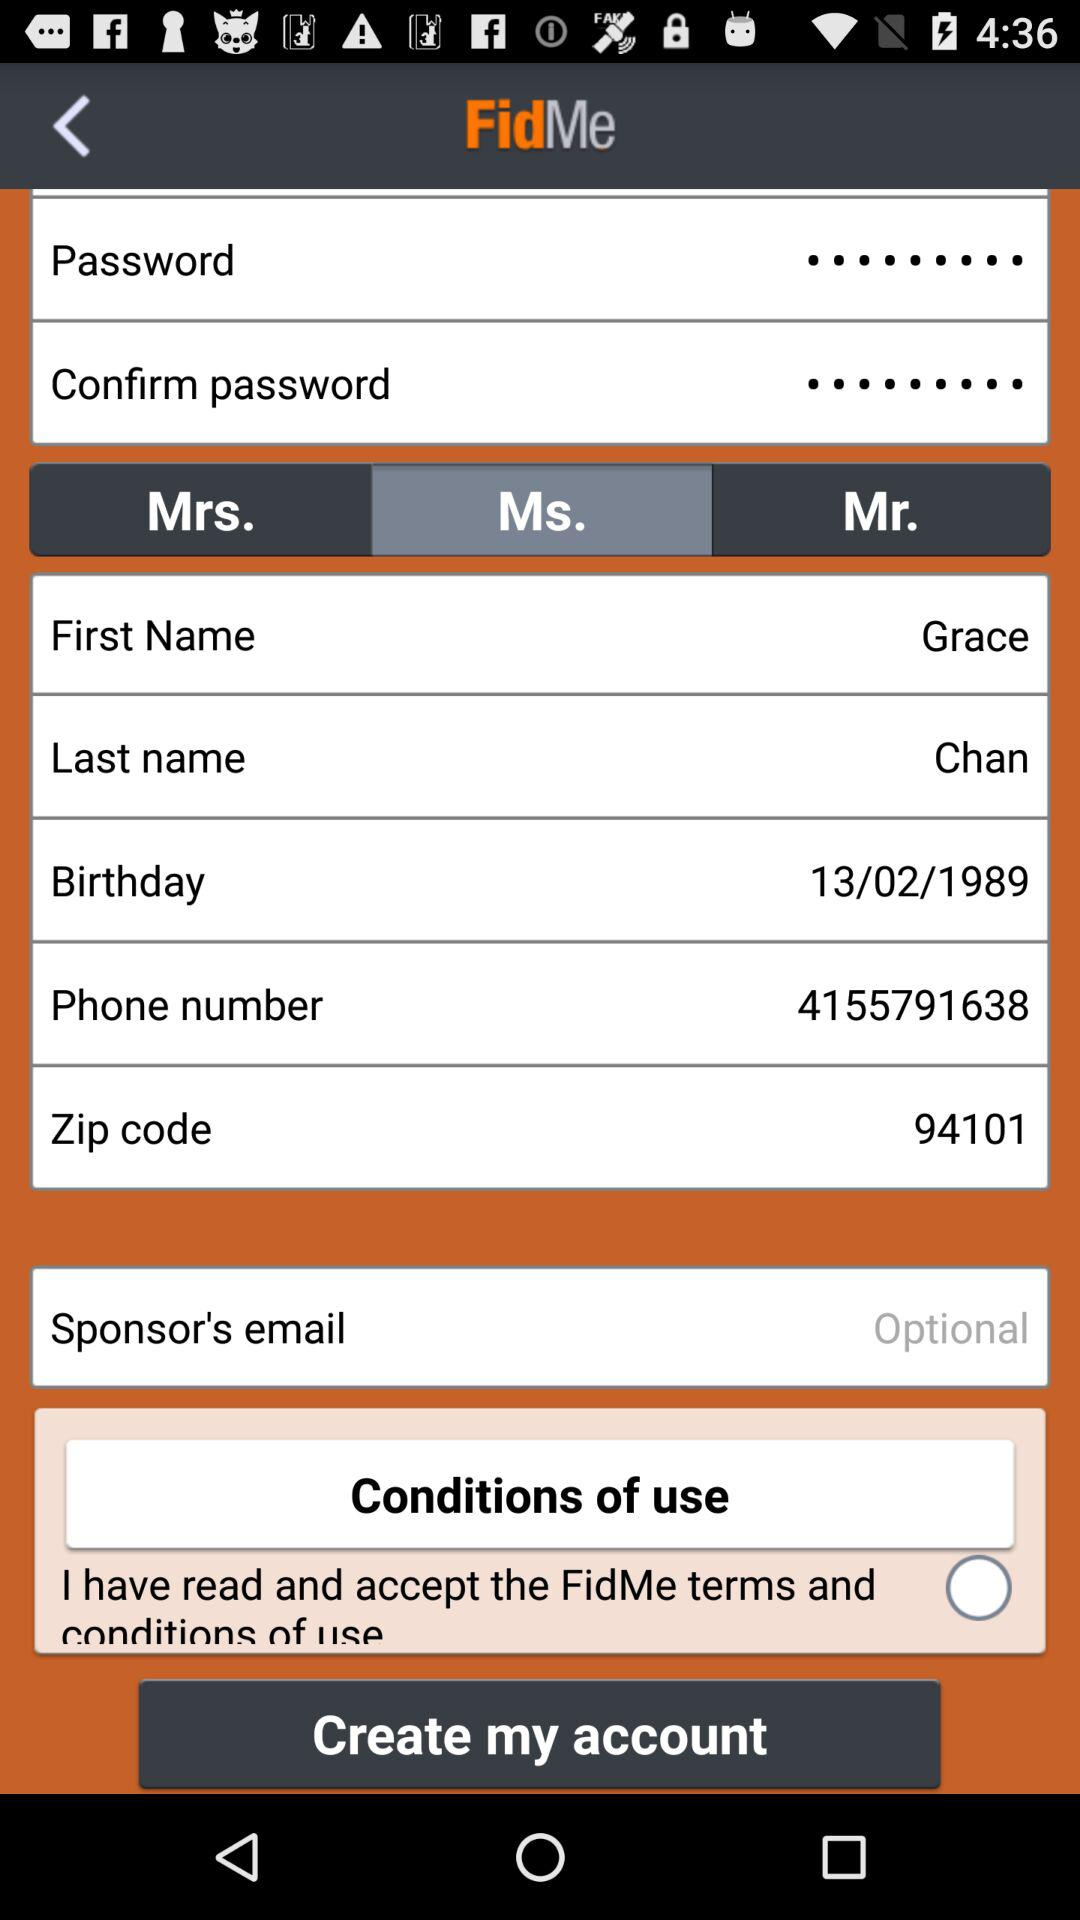How many text fields are there for the user to enter information?
Answer the question using a single word or phrase. 8 